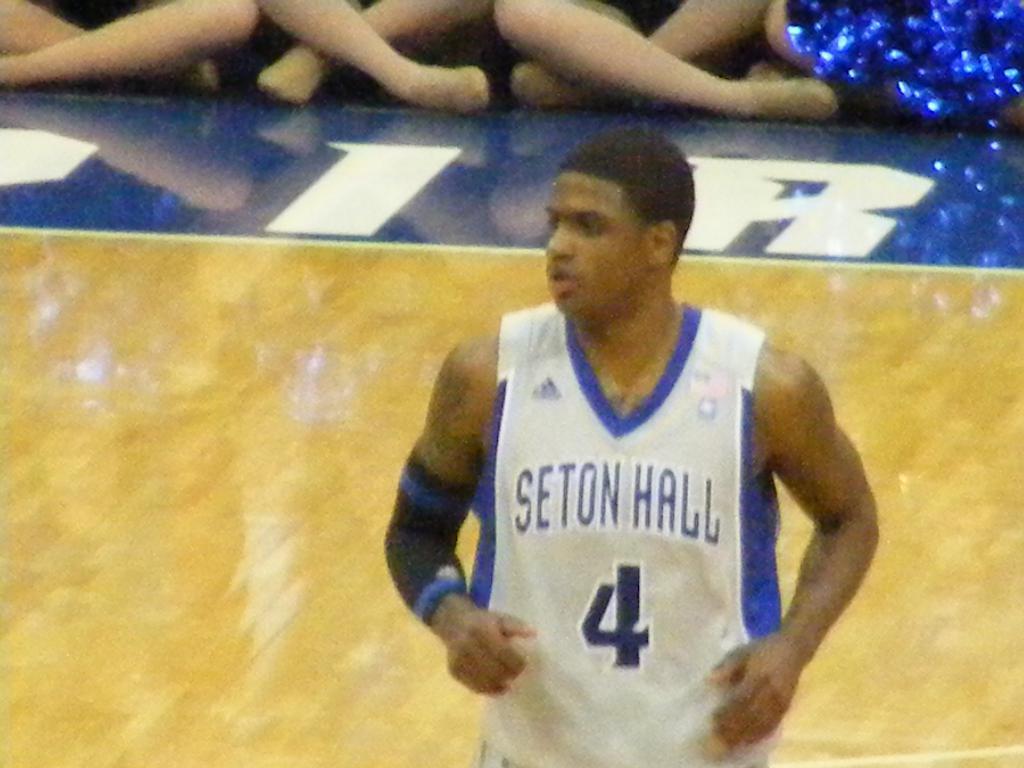Can you describe this image briefly? In this image we can see a person wearing blue and white color dress standing and in the background of the image there are some persons sitting on stage and we can see some blue color thing. 